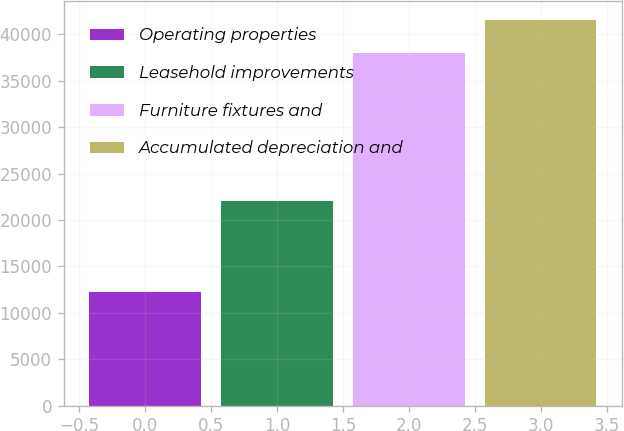Convert chart to OTSL. <chart><loc_0><loc_0><loc_500><loc_500><bar_chart><fcel>Operating properties<fcel>Leasehold improvements<fcel>Furniture fixtures and<fcel>Accumulated depreciation and<nl><fcel>12203<fcel>22027<fcel>37966<fcel>41544<nl></chart> 